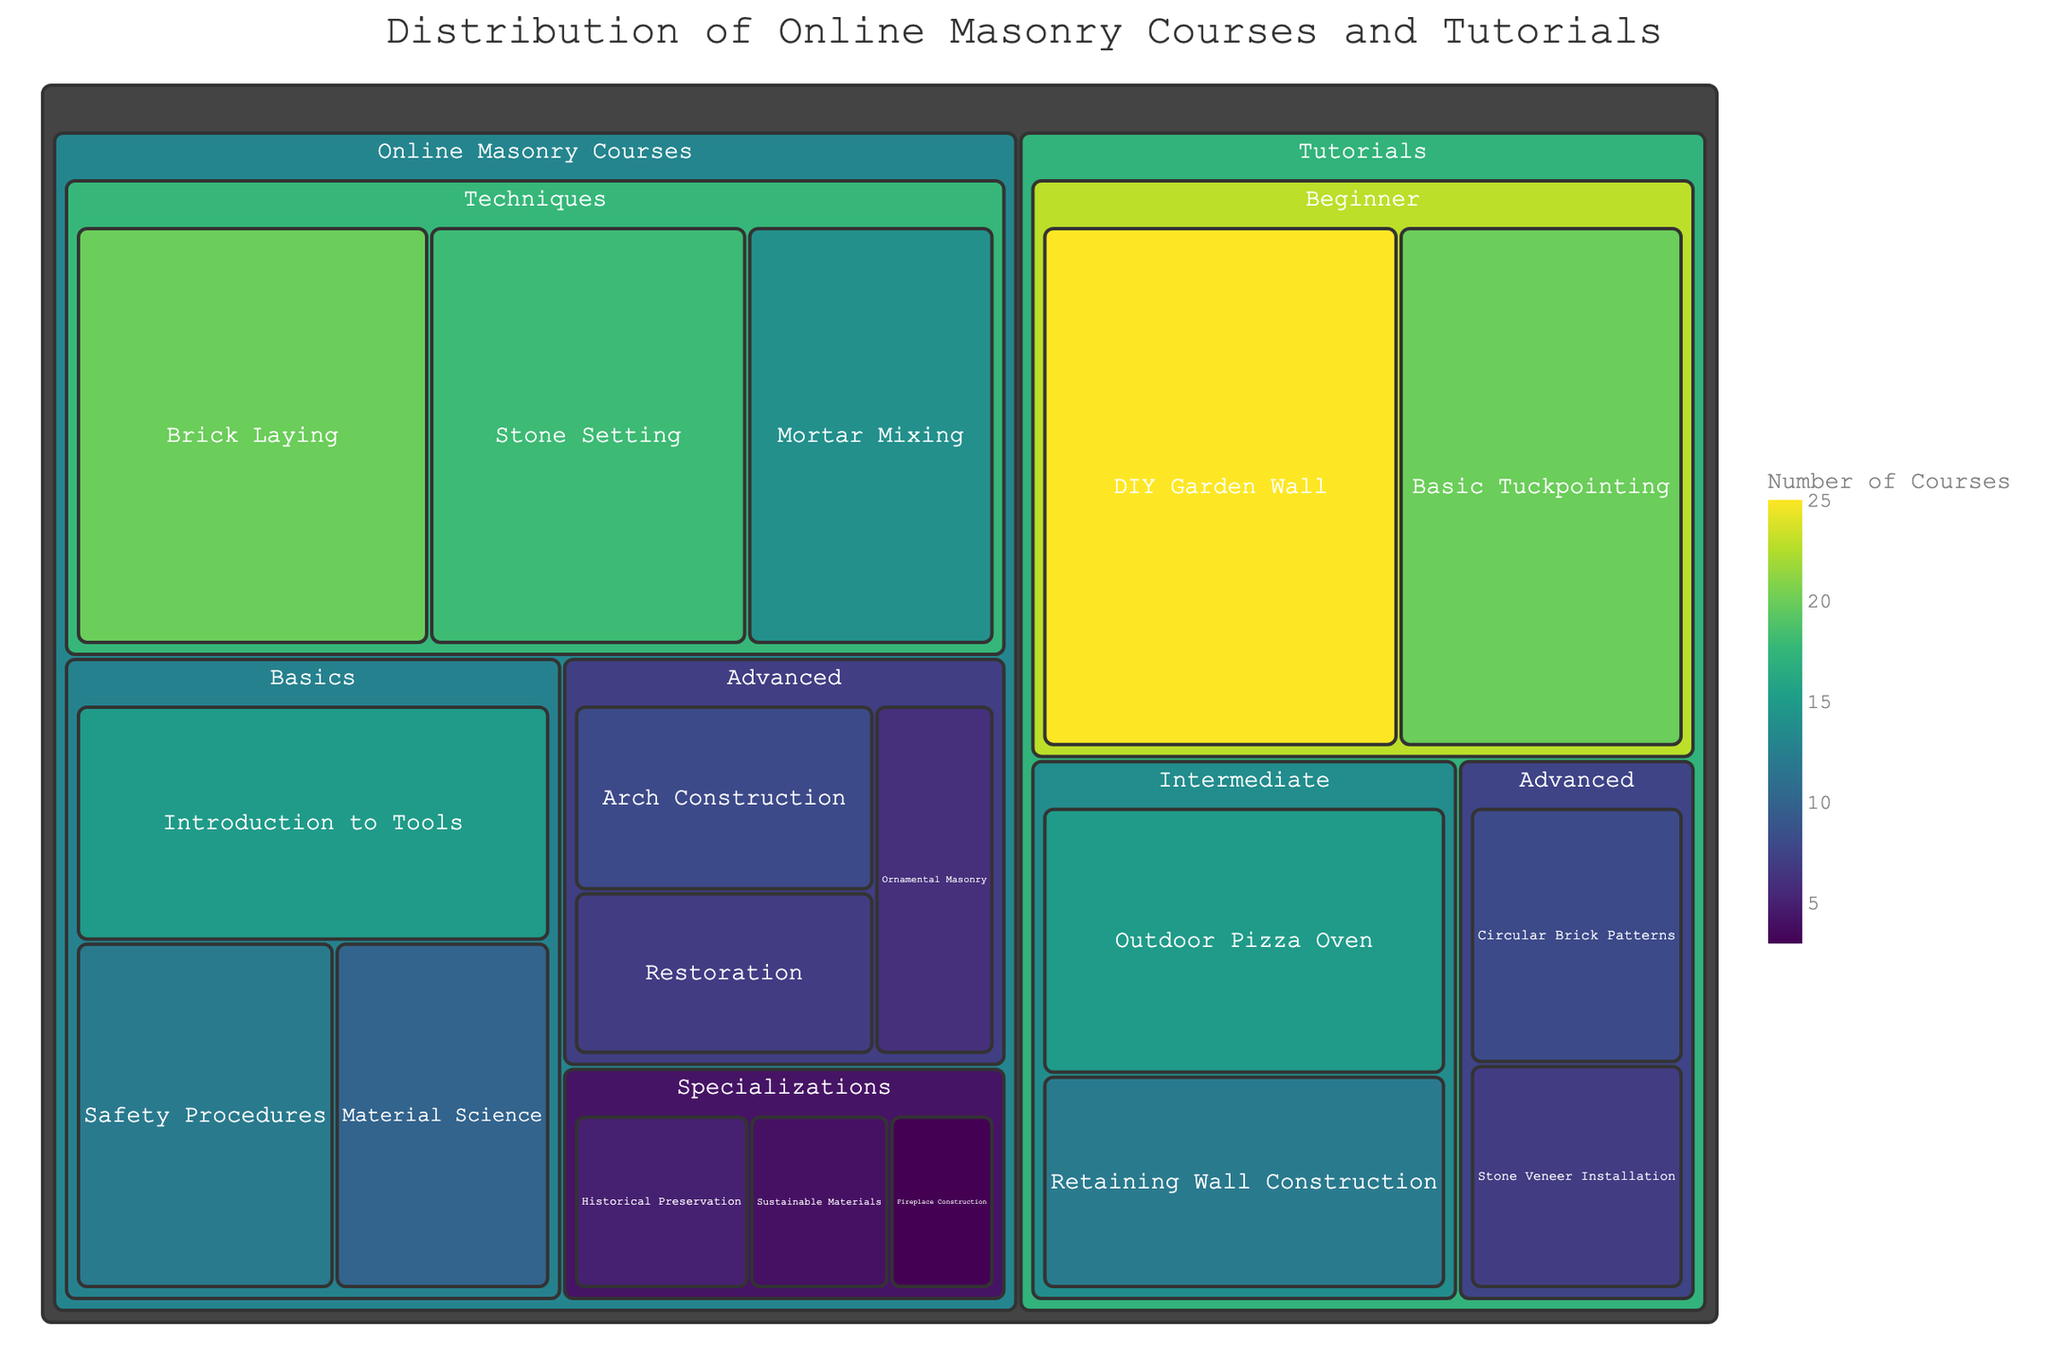What is the title of the figure? The title is usually shown at the top of the plot. In this case, it reads: "Distribution of Online Masonry Courses and Tutorials"
Answer: Distribution of Online Masonry Courses and Tutorials Which subcategory has the highest number of courses in the Tutorials section? By looking at the Tutorials section of the treemap, the subcategory with the largest area should represent the highest number of courses. "DIY Garden Wall" takes up the most space in the Tutorials section.
Answer: DIY Garden Wall What are the three subcategories under Basics in Online Masonry Courses? Each category under Basics is indicated by different sections in the treemap under the Online Masonry Courses. The three subcategories are "Introduction to Tools," "Safety Procedures," and "Material Science."
Answer: Introduction to Tools, Safety Procedures, Material Science How many courses are available under the Techniques category of Online Masonry Courses? Summing up the values from the treemap for each subcategory under Techniques provides the total number. Brick Laying (20) + Stone Setting (18) + Mortar Mixing (14) = 52.
Answer: 52 Which has more courses: Advanced tutorials or Advanced online masonry courses? Compare the sum of the values in the Advanced category from both sections. In Online Masonry Courses: Arch Construction (8) + Restoration (7) + Ornamental Masonry (6) = 21. For Tutorials: Circular Brick Patterns (8) + Stone Veneer Installation (7) = 15.
Answer: Advanced online masonry courses Under the Specializations category, which subcategory has the highest number of courses? In the Specializations category of Online Masonry Courses, the subcategory with the largest area and highest number is "Historical Preservation" with 5 courses.
Answer: Historical Preservation What is the total number of Beginner-level Tutorials? Add up the values for each subcategory under Beginner in the Tutorials. DIY Garden Wall (25) + Basic Tuckpointing (20) = 45.
Answer: 45 Which has a smaller number of courses: Safety Procedures or Fireplace Construction? Look at their respective areas in the treemap. Safety Procedures has 12 courses, while Fireplace Construction has 3.
Answer: Fireplace Construction In the Online Masonry Courses section, what is the largest subcategory under Techniques? Out of the subcategories under Techniques in Online Masonry Courses (Brick Laying, Stone Setting, Mortar Mixing), Brick Laying occupies the most space and has 20 courses.
Answer: Brick Laying Compare the number of courses in Introduction to Tools with Circular Brick Patterns. Which has more? Introduction to Tools in Basics category has 15 courses, and Circular Brick Patterns in Advanced Tutorials has 8. Introduction to Tools has more.
Answer: Introduction to Tools 